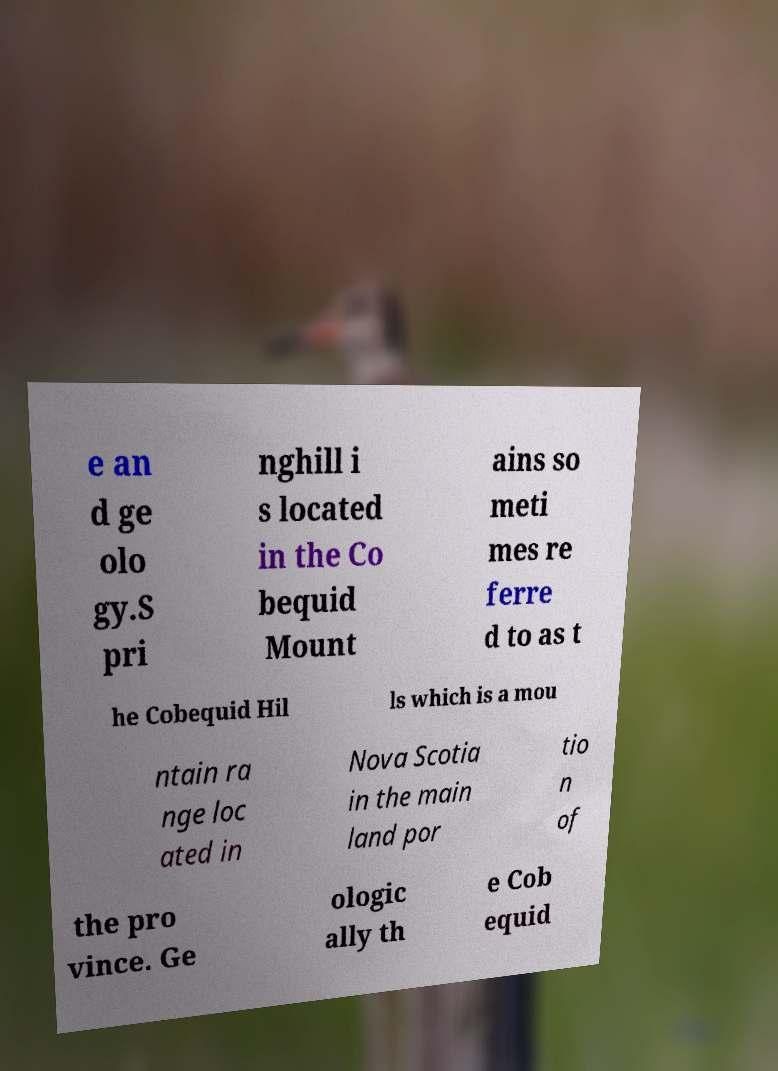Could you extract and type out the text from this image? e an d ge olo gy.S pri nghill i s located in the Co bequid Mount ains so meti mes re ferre d to as t he Cobequid Hil ls which is a mou ntain ra nge loc ated in Nova Scotia in the main land por tio n of the pro vince. Ge ologic ally th e Cob equid 